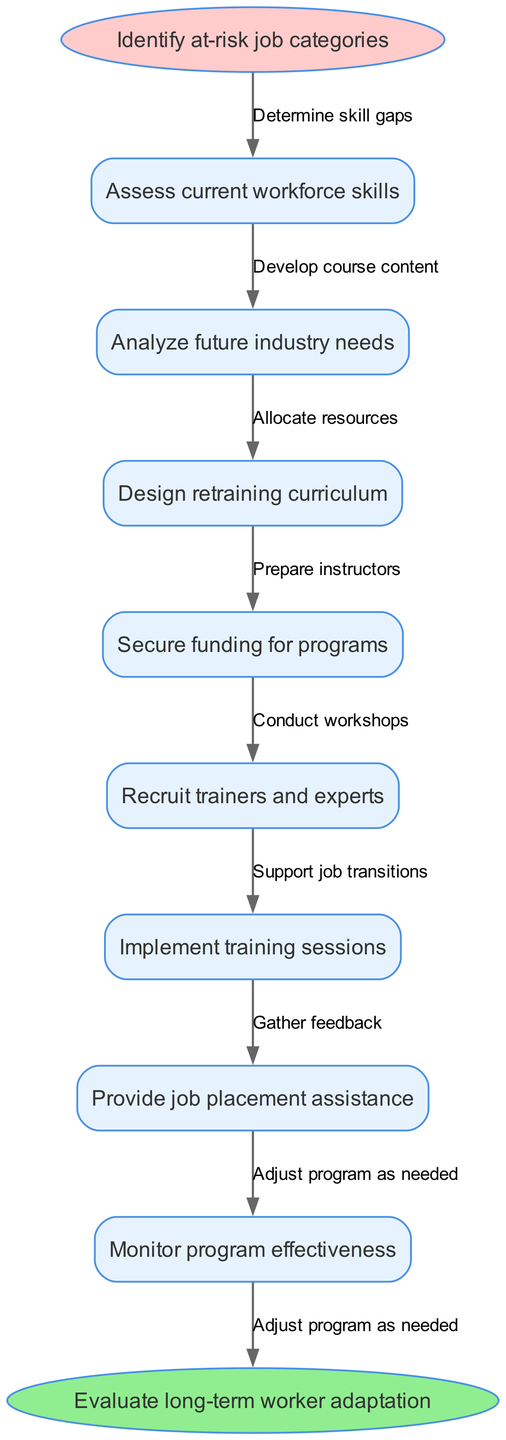What is the first action in the retraining program? The diagram begins with the action "Identify at-risk job categories" which is represented by the start node. Since it's the initial node, it directly indicates the first step in the flow.
Answer: Identify at-risk job categories How many main process nodes are there in the diagram? By counting the nodes listed from the "Assess current workforce skills" node to "Provide job placement assistance", there are a total of eight main process nodes that represent specific actions within the retraining program.
Answer: 8 What is the last action before evaluating long-term worker adaptation? The penultimate action before reaching "Evaluate long-term worker adaptation" is "Monitor program effectiveness", which is connected right before the final evaluation. Hence, it's the last step taken before the end node.
Answer: Monitor program effectiveness What action involves determining skill gaps? The edge labeled "Determine skill gaps" is specifically connected to the first main action "Assess current workforce skills", indicating that this is where the determination of skill gaps takes place.
Answer: Assess current workforce skills Which node requires recruitment of trainers and experts? The node "Recruit trainers and experts" is a specific action that involves the process of finding qualified individuals to lead the training sessions necessary for the program. This action is represented as one of the main process nodes.
Answer: Recruit trainers and experts How many edges are connecting the nodes in the flow chart? The flow chart connects all the main process nodes using edges, and considering there are eight nodes, there will be seven edges connecting them, plus one more connecting to the end node, leading to a total of eight edges.
Answer: 8 What action do we take after designing the retraining curriculum? According to the flow of the diagram, the next action after "Design retraining curriculum" is "Secure funding for programs," indicating that funding is secured following the curriculum design phase.
Answer: Secure funding for programs What does the node "Gather feedback" relate to in the flow? The node "Gather feedback" is associated with "Monitor program effectiveness," which suggests that feedback is collected after the training sessions to assess the outcomes and make necessary adjustments.
Answer: Monitor program effectiveness What must be done before implementing training sessions? The edge "Prepare instructors" shows that preparation of instructors must occur following the action "Recruit trainers and experts" but before the implementation of the training sessions. This indicates that instructor readiness is crucial beforehand.
Answer: Prepare instructors 